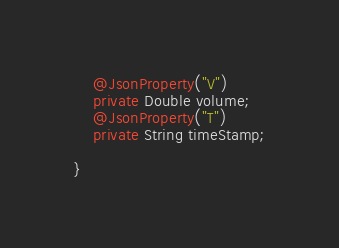Convert code to text. <code><loc_0><loc_0><loc_500><loc_500><_Java_>	@JsonProperty("V")
	private Double volume;
	@JsonProperty("T")
	private String timeStamp;
	
}
</code> 